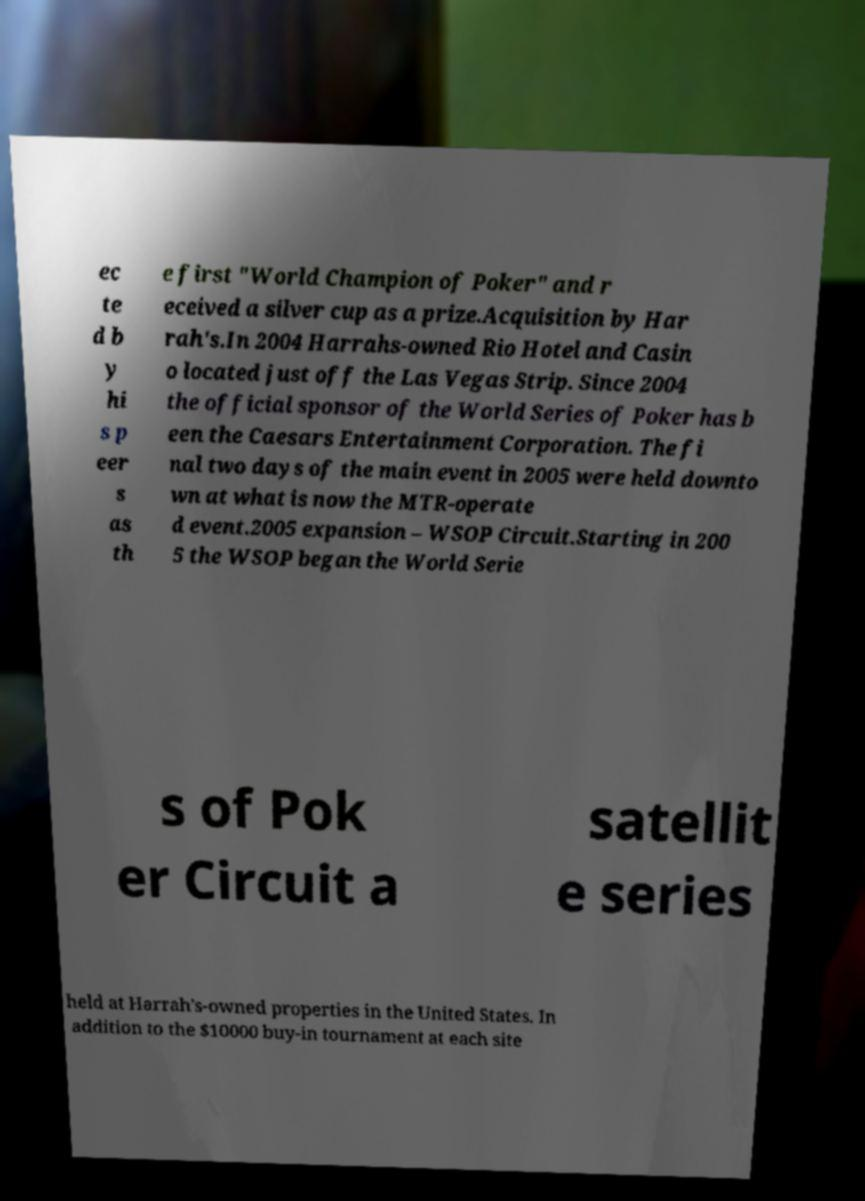What messages or text are displayed in this image? I need them in a readable, typed format. ec te d b y hi s p eer s as th e first "World Champion of Poker" and r eceived a silver cup as a prize.Acquisition by Har rah's.In 2004 Harrahs-owned Rio Hotel and Casin o located just off the Las Vegas Strip. Since 2004 the official sponsor of the World Series of Poker has b een the Caesars Entertainment Corporation. The fi nal two days of the main event in 2005 were held downto wn at what is now the MTR-operate d event.2005 expansion – WSOP Circuit.Starting in 200 5 the WSOP began the World Serie s of Pok er Circuit a satellit e series held at Harrah's-owned properties in the United States. In addition to the $10000 buy-in tournament at each site 